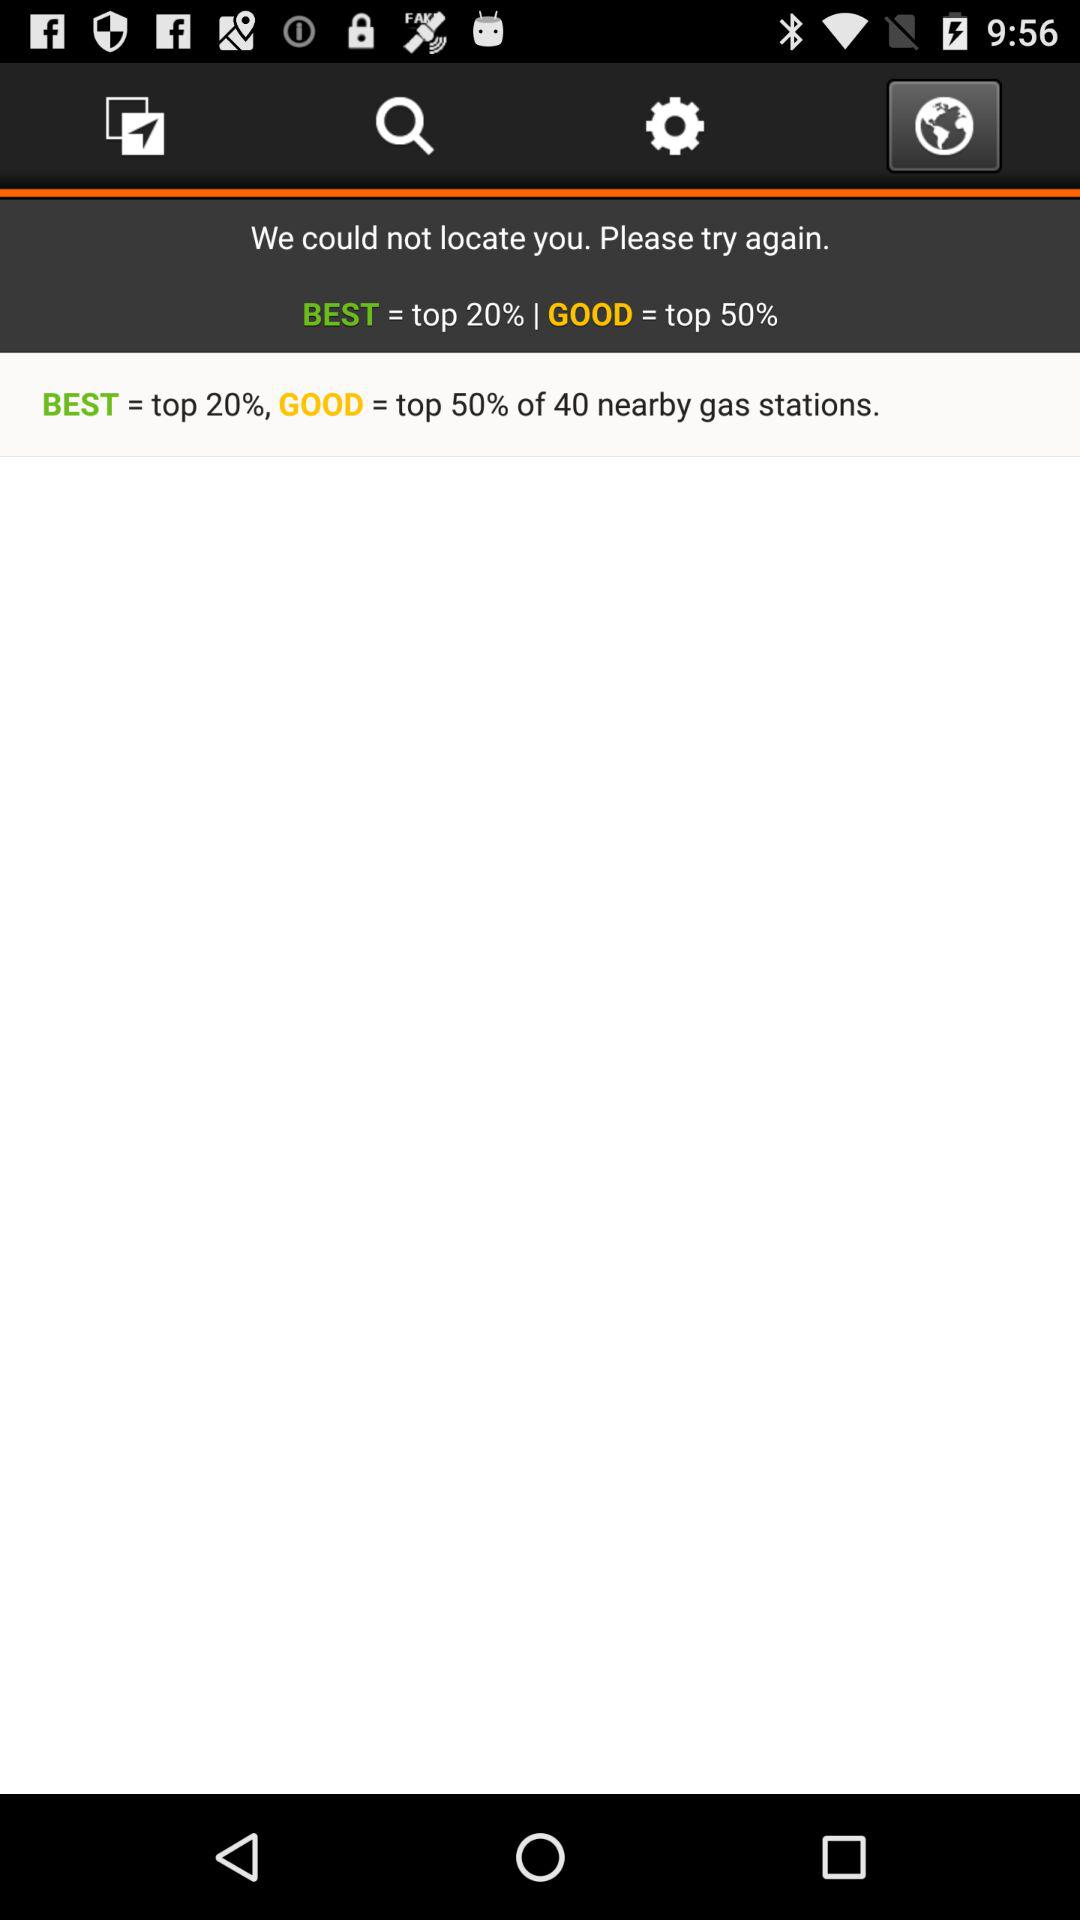What is "GOOD" equal to? "GOOD" is equal to the top 50%. 